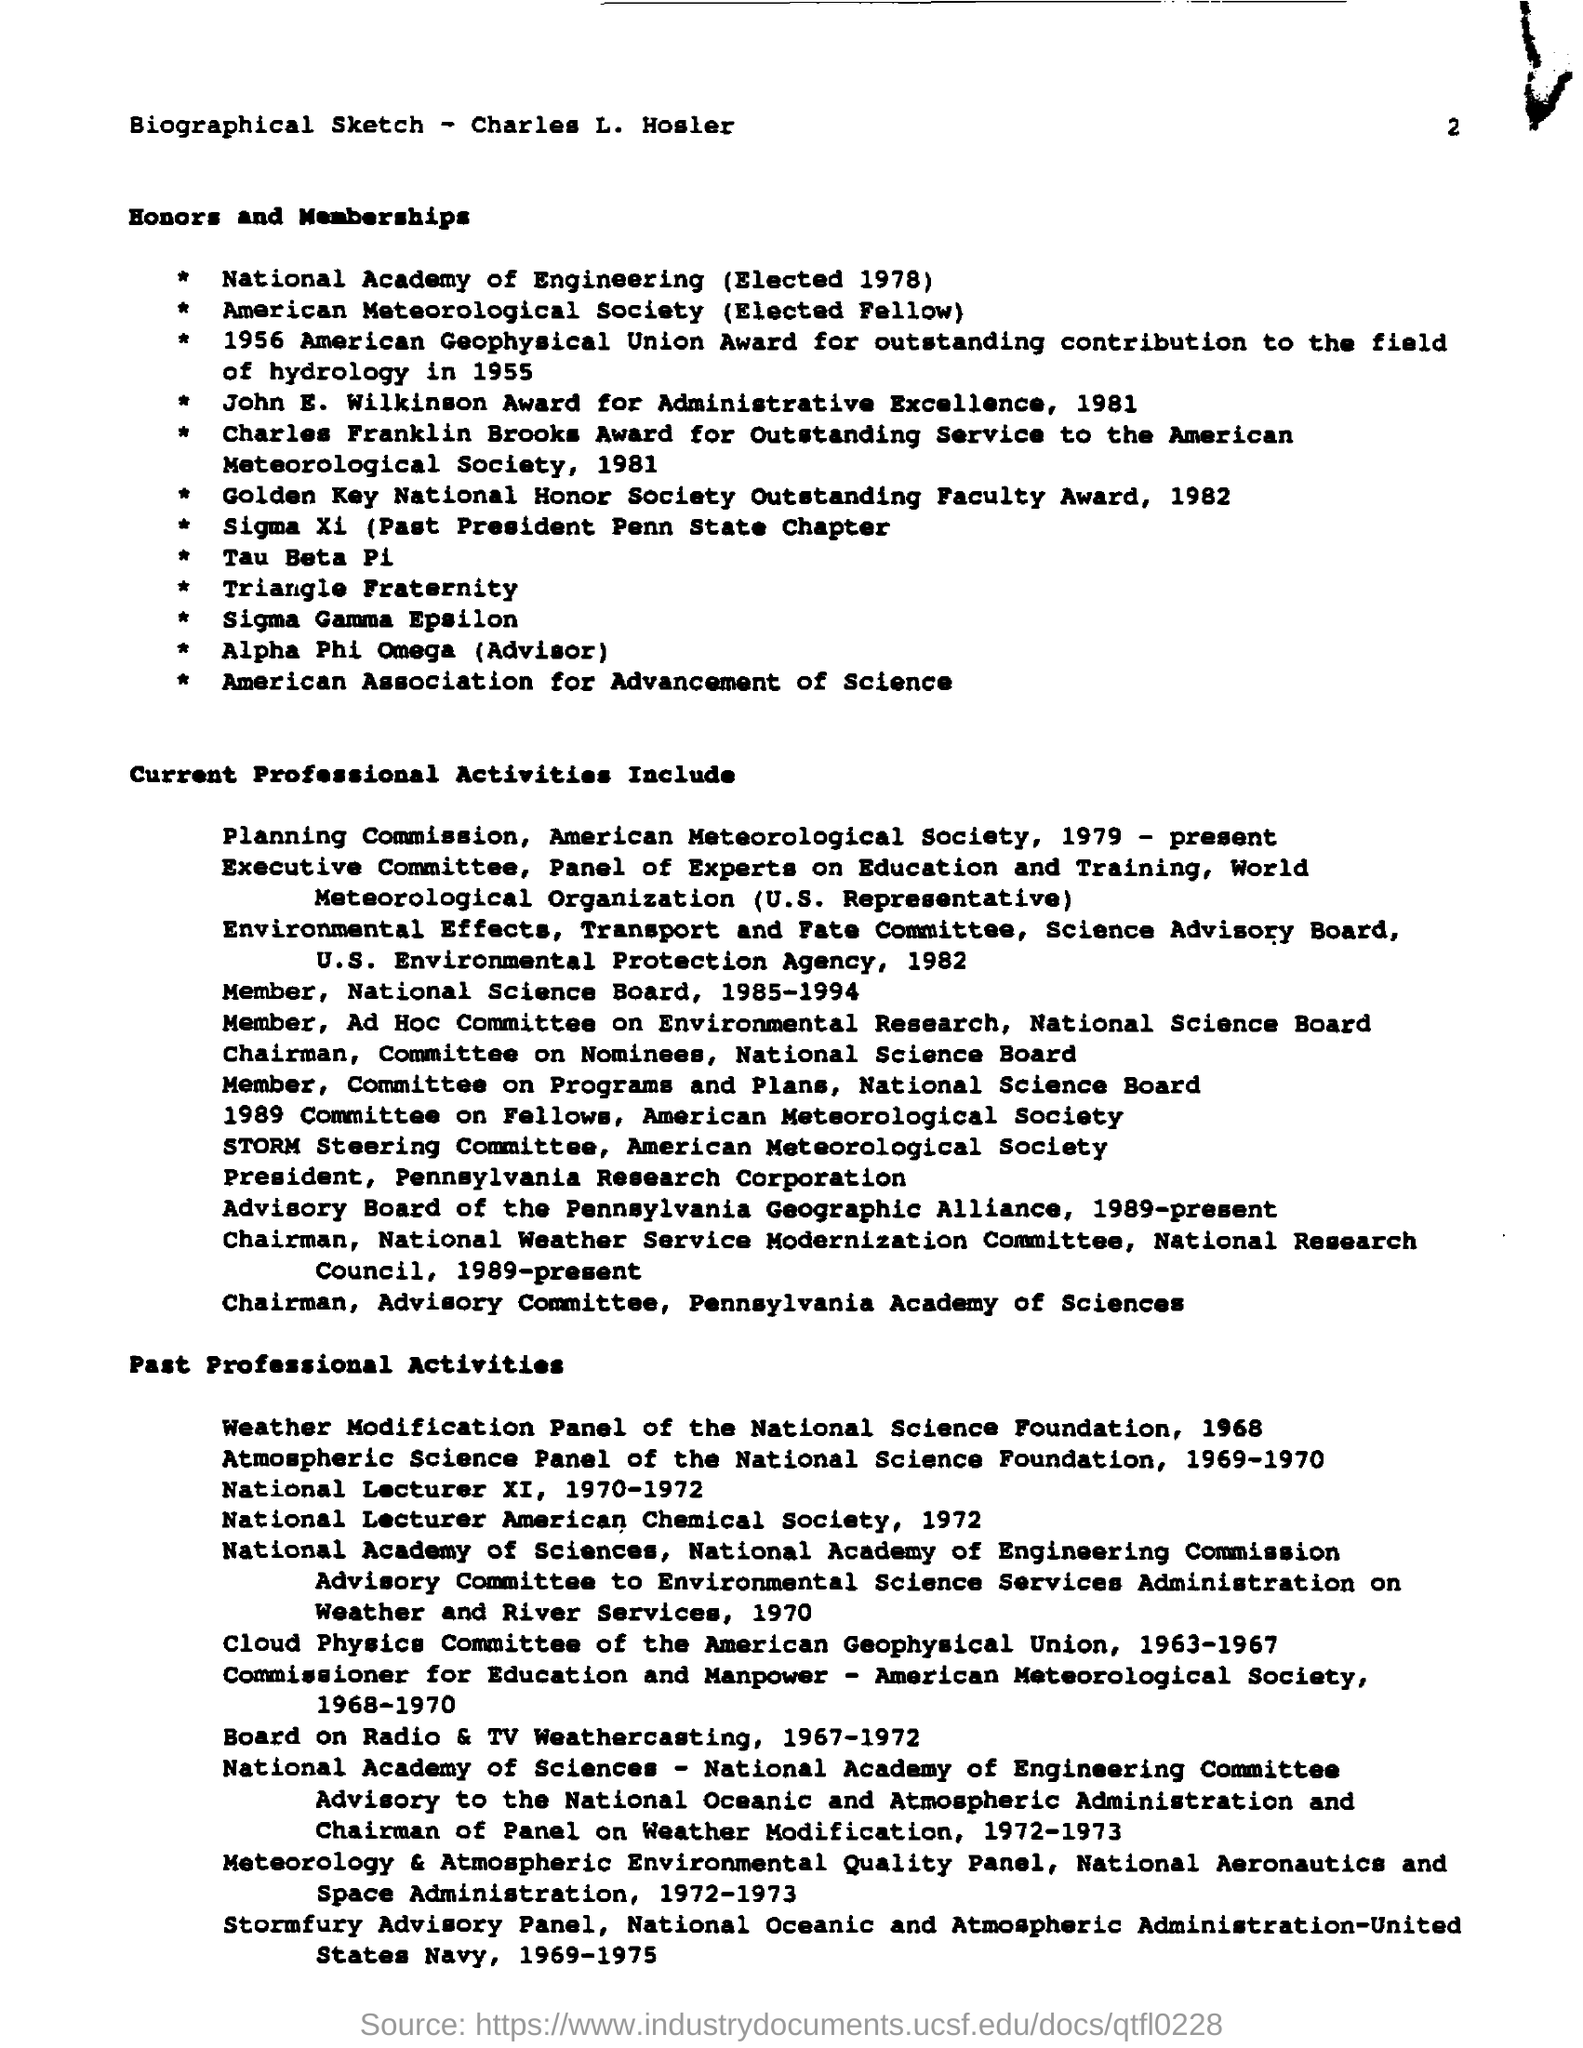What is the document about?
Provide a succinct answer. Biographical Sketch - Charles L. Hosler. When was Charles L. Hosler elected to the National Academy of Engineering
Make the answer very short. 1978. Which award did Charles receive for outstanding contribution to the field of hydrology in 1955?
Provide a short and direct response. 1956 American Geophysical Union Award. Whose biographical sketch is given here?
Ensure brevity in your answer.  Charles L. Hosler. 